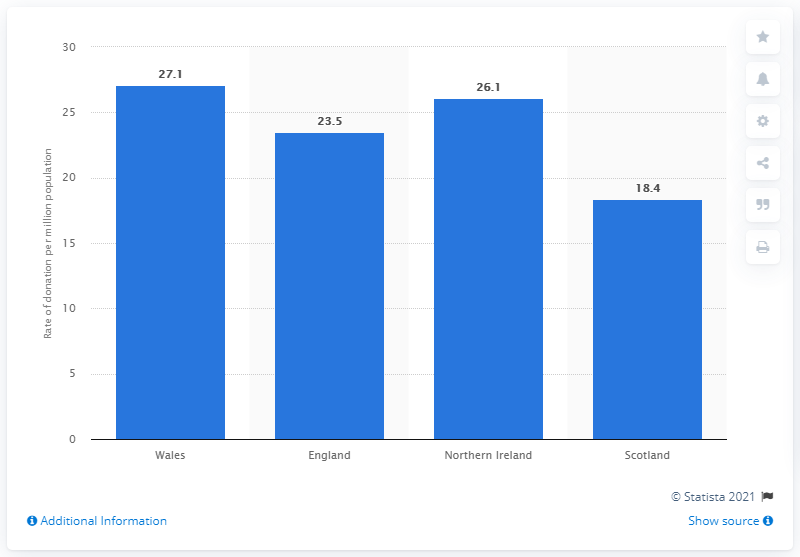Mention a couple of crucial points in this snapshot. In the 2019/2020 fiscal year, the organ donation rate in Wales was 27.1%. The country with the lowest organ donation rate in the United Kingdom during the 2019/2020 period was Scotland. The highest organ donation rate in the UK is in Wales. England had the second highest organ donation rate in 2019/20. 